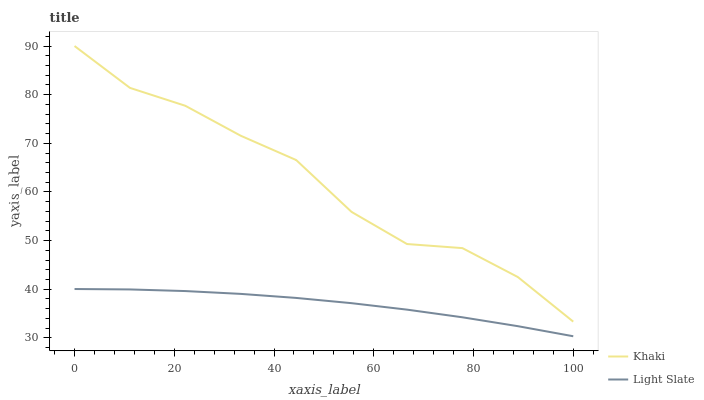Does Light Slate have the minimum area under the curve?
Answer yes or no. Yes. Does Khaki have the maximum area under the curve?
Answer yes or no. Yes. Does Khaki have the minimum area under the curve?
Answer yes or no. No. Is Light Slate the smoothest?
Answer yes or no. Yes. Is Khaki the roughest?
Answer yes or no. Yes. Is Khaki the smoothest?
Answer yes or no. No. Does Light Slate have the lowest value?
Answer yes or no. Yes. Does Khaki have the lowest value?
Answer yes or no. No. Does Khaki have the highest value?
Answer yes or no. Yes. Is Light Slate less than Khaki?
Answer yes or no. Yes. Is Khaki greater than Light Slate?
Answer yes or no. Yes. Does Light Slate intersect Khaki?
Answer yes or no. No. 